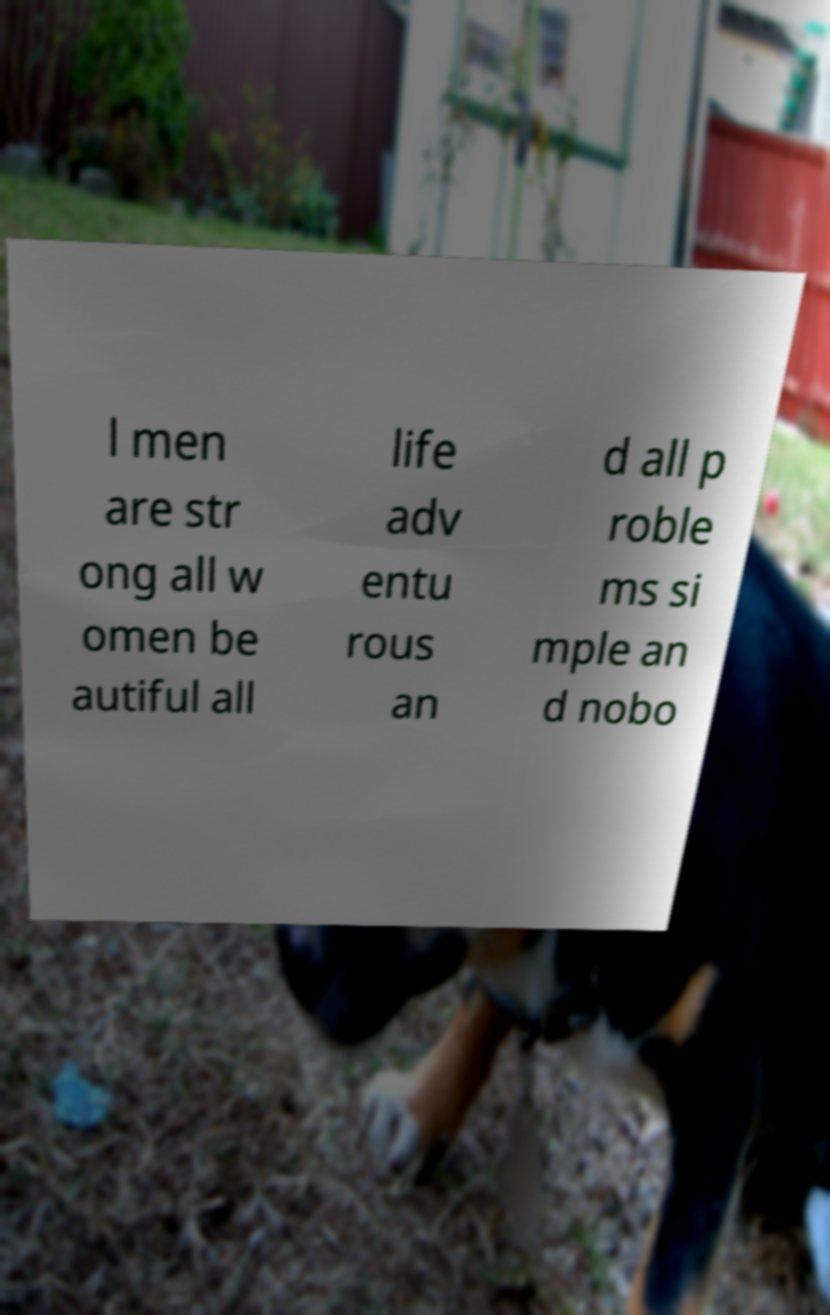For documentation purposes, I need the text within this image transcribed. Could you provide that? l men are str ong all w omen be autiful all life adv entu rous an d all p roble ms si mple an d nobo 